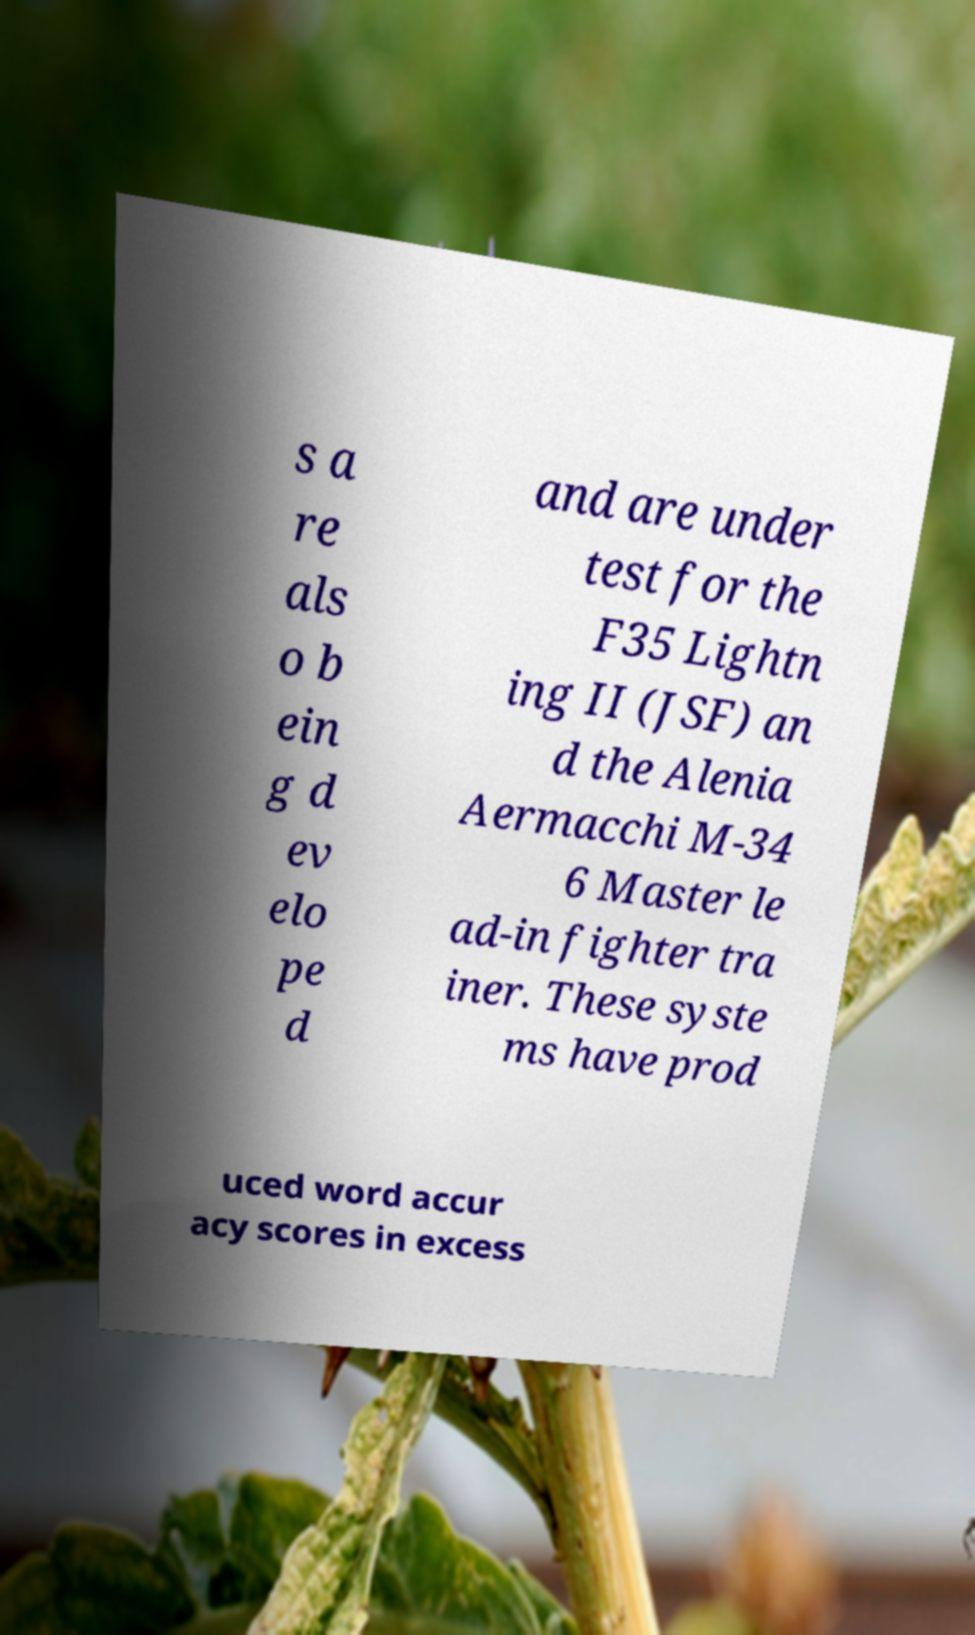Please identify and transcribe the text found in this image. s a re als o b ein g d ev elo pe d and are under test for the F35 Lightn ing II (JSF) an d the Alenia Aermacchi M-34 6 Master le ad-in fighter tra iner. These syste ms have prod uced word accur acy scores in excess 